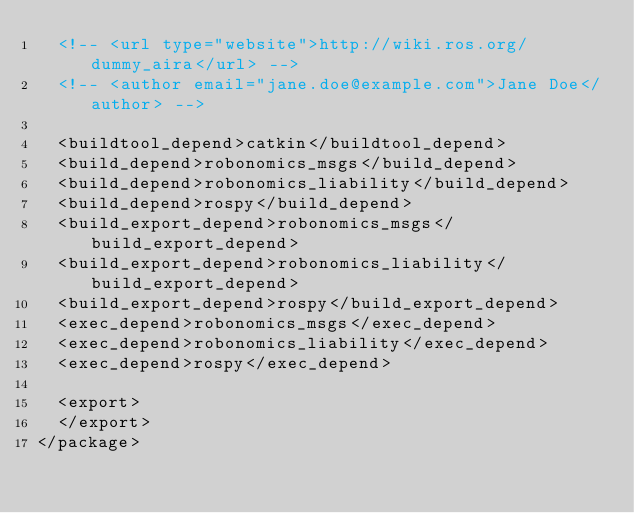<code> <loc_0><loc_0><loc_500><loc_500><_XML_>  <!-- <url type="website">http://wiki.ros.org/dummy_aira</url> -->
  <!-- <author email="jane.doe@example.com">Jane Doe</author> -->

  <buildtool_depend>catkin</buildtool_depend>
  <build_depend>robonomics_msgs</build_depend>
  <build_depend>robonomics_liability</build_depend>
  <build_depend>rospy</build_depend>
  <build_export_depend>robonomics_msgs</build_export_depend>
  <build_export_depend>robonomics_liability</build_export_depend>
  <build_export_depend>rospy</build_export_depend>
  <exec_depend>robonomics_msgs</exec_depend>
  <exec_depend>robonomics_liability</exec_depend>
  <exec_depend>rospy</exec_depend>

  <export>
  </export>
</package>
</code> 